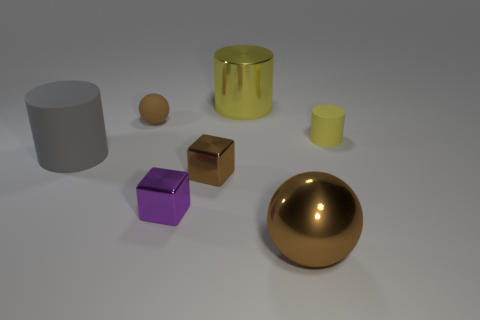There is a brown rubber object; is its shape the same as the gray matte object behind the purple thing?
Make the answer very short. No. What number of big yellow things are right of the small matte thing that is to the right of the small rubber object to the left of the large metallic ball?
Your answer should be compact. 0. The other large object that is the same shape as the yellow metallic thing is what color?
Provide a short and direct response. Gray. Is there any other thing that has the same shape as the big yellow metallic object?
Keep it short and to the point. Yes. What number of cubes are either tiny brown metal things or tiny purple shiny objects?
Provide a succinct answer. 2. What is the shape of the brown rubber object?
Your answer should be compact. Sphere. There is a tiny brown matte object; are there any brown rubber spheres in front of it?
Offer a very short reply. No. Is the material of the small cylinder the same as the sphere that is behind the gray matte object?
Give a very brief answer. Yes. Does the large shiny thing behind the big brown thing have the same shape as the yellow rubber thing?
Your response must be concise. Yes. What number of big yellow cylinders are made of the same material as the tiny yellow cylinder?
Give a very brief answer. 0. 